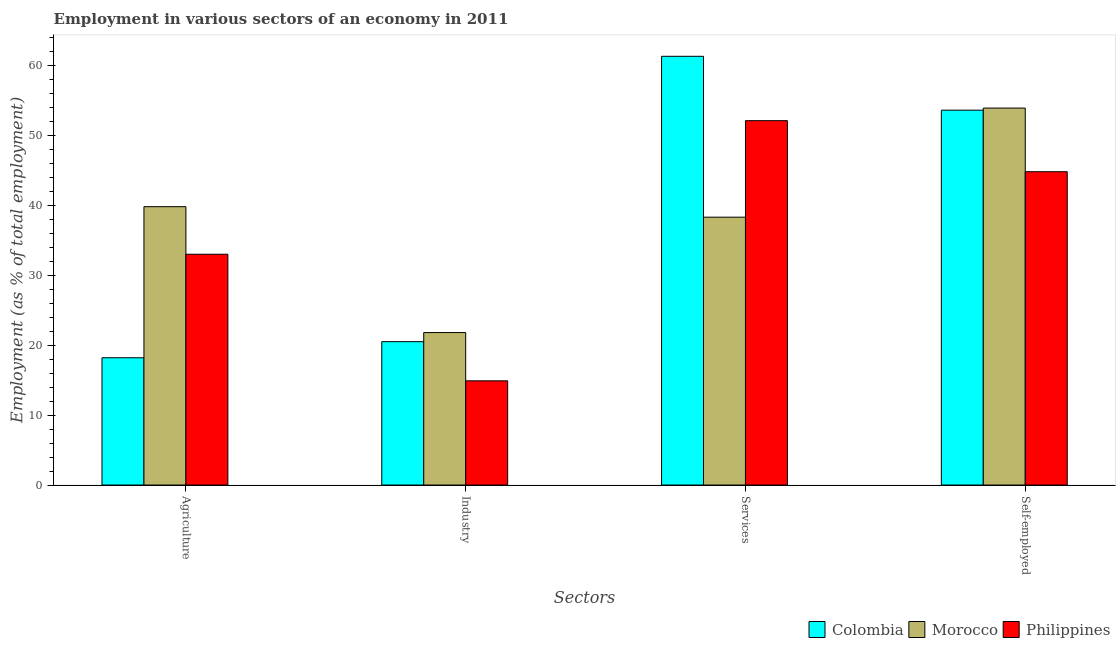How many different coloured bars are there?
Keep it short and to the point. 3. Are the number of bars per tick equal to the number of legend labels?
Ensure brevity in your answer.  Yes. How many bars are there on the 3rd tick from the left?
Make the answer very short. 3. How many bars are there on the 4th tick from the right?
Give a very brief answer. 3. What is the label of the 4th group of bars from the left?
Ensure brevity in your answer.  Self-employed. Across all countries, what is the maximum percentage of workers in services?
Make the answer very short. 61.3. Across all countries, what is the minimum percentage of self employed workers?
Offer a very short reply. 44.8. In which country was the percentage of workers in industry maximum?
Your answer should be very brief. Morocco. In which country was the percentage of self employed workers minimum?
Your answer should be compact. Philippines. What is the total percentage of workers in industry in the graph?
Keep it short and to the point. 57.2. What is the difference between the percentage of self employed workers in Philippines and that in Colombia?
Provide a short and direct response. -8.8. What is the difference between the percentage of workers in industry in Colombia and the percentage of self employed workers in Morocco?
Your answer should be compact. -33.4. What is the average percentage of workers in industry per country?
Make the answer very short. 19.07. What is the difference between the percentage of workers in services and percentage of workers in agriculture in Colombia?
Make the answer very short. 43.1. In how many countries, is the percentage of self employed workers greater than 24 %?
Provide a short and direct response. 3. What is the ratio of the percentage of workers in agriculture in Colombia to that in Philippines?
Keep it short and to the point. 0.55. Is the percentage of self employed workers in Morocco less than that in Philippines?
Provide a succinct answer. No. Is the difference between the percentage of workers in agriculture in Philippines and Morocco greater than the difference between the percentage of self employed workers in Philippines and Morocco?
Keep it short and to the point. Yes. What is the difference between the highest and the second highest percentage of self employed workers?
Offer a terse response. 0.3. What is the difference between the highest and the lowest percentage of workers in industry?
Offer a very short reply. 6.9. Is it the case that in every country, the sum of the percentage of workers in services and percentage of self employed workers is greater than the sum of percentage of workers in agriculture and percentage of workers in industry?
Keep it short and to the point. No. What does the 2nd bar from the left in Agriculture represents?
Make the answer very short. Morocco. What does the 2nd bar from the right in Services represents?
Offer a very short reply. Morocco. Are all the bars in the graph horizontal?
Ensure brevity in your answer.  No. What is the difference between two consecutive major ticks on the Y-axis?
Provide a short and direct response. 10. Are the values on the major ticks of Y-axis written in scientific E-notation?
Offer a very short reply. No. Does the graph contain any zero values?
Offer a very short reply. No. Does the graph contain grids?
Provide a succinct answer. No. Where does the legend appear in the graph?
Your response must be concise. Bottom right. How are the legend labels stacked?
Your response must be concise. Horizontal. What is the title of the graph?
Provide a succinct answer. Employment in various sectors of an economy in 2011. What is the label or title of the X-axis?
Your answer should be very brief. Sectors. What is the label or title of the Y-axis?
Offer a very short reply. Employment (as % of total employment). What is the Employment (as % of total employment) of Colombia in Agriculture?
Make the answer very short. 18.2. What is the Employment (as % of total employment) in Morocco in Agriculture?
Provide a short and direct response. 39.8. What is the Employment (as % of total employment) in Philippines in Agriculture?
Keep it short and to the point. 33. What is the Employment (as % of total employment) of Colombia in Industry?
Give a very brief answer. 20.5. What is the Employment (as % of total employment) in Morocco in Industry?
Keep it short and to the point. 21.8. What is the Employment (as % of total employment) in Philippines in Industry?
Offer a terse response. 14.9. What is the Employment (as % of total employment) of Colombia in Services?
Provide a short and direct response. 61.3. What is the Employment (as % of total employment) of Morocco in Services?
Make the answer very short. 38.3. What is the Employment (as % of total employment) of Philippines in Services?
Provide a short and direct response. 52.1. What is the Employment (as % of total employment) of Colombia in Self-employed?
Offer a terse response. 53.6. What is the Employment (as % of total employment) of Morocco in Self-employed?
Provide a succinct answer. 53.9. What is the Employment (as % of total employment) of Philippines in Self-employed?
Offer a terse response. 44.8. Across all Sectors, what is the maximum Employment (as % of total employment) in Colombia?
Your response must be concise. 61.3. Across all Sectors, what is the maximum Employment (as % of total employment) of Morocco?
Offer a terse response. 53.9. Across all Sectors, what is the maximum Employment (as % of total employment) of Philippines?
Give a very brief answer. 52.1. Across all Sectors, what is the minimum Employment (as % of total employment) of Colombia?
Your answer should be compact. 18.2. Across all Sectors, what is the minimum Employment (as % of total employment) of Morocco?
Your answer should be very brief. 21.8. Across all Sectors, what is the minimum Employment (as % of total employment) in Philippines?
Ensure brevity in your answer.  14.9. What is the total Employment (as % of total employment) in Colombia in the graph?
Make the answer very short. 153.6. What is the total Employment (as % of total employment) in Morocco in the graph?
Provide a succinct answer. 153.8. What is the total Employment (as % of total employment) of Philippines in the graph?
Offer a very short reply. 144.8. What is the difference between the Employment (as % of total employment) of Morocco in Agriculture and that in Industry?
Give a very brief answer. 18. What is the difference between the Employment (as % of total employment) in Colombia in Agriculture and that in Services?
Your response must be concise. -43.1. What is the difference between the Employment (as % of total employment) in Philippines in Agriculture and that in Services?
Provide a succinct answer. -19.1. What is the difference between the Employment (as % of total employment) of Colombia in Agriculture and that in Self-employed?
Make the answer very short. -35.4. What is the difference between the Employment (as % of total employment) in Morocco in Agriculture and that in Self-employed?
Ensure brevity in your answer.  -14.1. What is the difference between the Employment (as % of total employment) in Philippines in Agriculture and that in Self-employed?
Keep it short and to the point. -11.8. What is the difference between the Employment (as % of total employment) in Colombia in Industry and that in Services?
Ensure brevity in your answer.  -40.8. What is the difference between the Employment (as % of total employment) in Morocco in Industry and that in Services?
Provide a succinct answer. -16.5. What is the difference between the Employment (as % of total employment) in Philippines in Industry and that in Services?
Your answer should be very brief. -37.2. What is the difference between the Employment (as % of total employment) of Colombia in Industry and that in Self-employed?
Make the answer very short. -33.1. What is the difference between the Employment (as % of total employment) in Morocco in Industry and that in Self-employed?
Your response must be concise. -32.1. What is the difference between the Employment (as % of total employment) of Philippines in Industry and that in Self-employed?
Your answer should be compact. -29.9. What is the difference between the Employment (as % of total employment) of Morocco in Services and that in Self-employed?
Give a very brief answer. -15.6. What is the difference between the Employment (as % of total employment) of Philippines in Services and that in Self-employed?
Your answer should be compact. 7.3. What is the difference between the Employment (as % of total employment) in Colombia in Agriculture and the Employment (as % of total employment) in Morocco in Industry?
Offer a very short reply. -3.6. What is the difference between the Employment (as % of total employment) in Colombia in Agriculture and the Employment (as % of total employment) in Philippines in Industry?
Give a very brief answer. 3.3. What is the difference between the Employment (as % of total employment) in Morocco in Agriculture and the Employment (as % of total employment) in Philippines in Industry?
Your answer should be compact. 24.9. What is the difference between the Employment (as % of total employment) of Colombia in Agriculture and the Employment (as % of total employment) of Morocco in Services?
Offer a terse response. -20.1. What is the difference between the Employment (as % of total employment) of Colombia in Agriculture and the Employment (as % of total employment) of Philippines in Services?
Your answer should be compact. -33.9. What is the difference between the Employment (as % of total employment) of Morocco in Agriculture and the Employment (as % of total employment) of Philippines in Services?
Offer a very short reply. -12.3. What is the difference between the Employment (as % of total employment) in Colombia in Agriculture and the Employment (as % of total employment) in Morocco in Self-employed?
Keep it short and to the point. -35.7. What is the difference between the Employment (as % of total employment) of Colombia in Agriculture and the Employment (as % of total employment) of Philippines in Self-employed?
Your answer should be compact. -26.6. What is the difference between the Employment (as % of total employment) in Colombia in Industry and the Employment (as % of total employment) in Morocco in Services?
Your answer should be compact. -17.8. What is the difference between the Employment (as % of total employment) of Colombia in Industry and the Employment (as % of total employment) of Philippines in Services?
Your answer should be compact. -31.6. What is the difference between the Employment (as % of total employment) in Morocco in Industry and the Employment (as % of total employment) in Philippines in Services?
Ensure brevity in your answer.  -30.3. What is the difference between the Employment (as % of total employment) of Colombia in Industry and the Employment (as % of total employment) of Morocco in Self-employed?
Give a very brief answer. -33.4. What is the difference between the Employment (as % of total employment) in Colombia in Industry and the Employment (as % of total employment) in Philippines in Self-employed?
Your answer should be compact. -24.3. What is the difference between the Employment (as % of total employment) of Morocco in Industry and the Employment (as % of total employment) of Philippines in Self-employed?
Keep it short and to the point. -23. What is the difference between the Employment (as % of total employment) in Colombia in Services and the Employment (as % of total employment) in Morocco in Self-employed?
Offer a terse response. 7.4. What is the difference between the Employment (as % of total employment) of Colombia in Services and the Employment (as % of total employment) of Philippines in Self-employed?
Provide a succinct answer. 16.5. What is the average Employment (as % of total employment) of Colombia per Sectors?
Make the answer very short. 38.4. What is the average Employment (as % of total employment) of Morocco per Sectors?
Keep it short and to the point. 38.45. What is the average Employment (as % of total employment) in Philippines per Sectors?
Your answer should be compact. 36.2. What is the difference between the Employment (as % of total employment) of Colombia and Employment (as % of total employment) of Morocco in Agriculture?
Offer a terse response. -21.6. What is the difference between the Employment (as % of total employment) in Colombia and Employment (as % of total employment) in Philippines in Agriculture?
Offer a terse response. -14.8. What is the difference between the Employment (as % of total employment) of Morocco and Employment (as % of total employment) of Philippines in Agriculture?
Your answer should be very brief. 6.8. What is the difference between the Employment (as % of total employment) of Colombia and Employment (as % of total employment) of Philippines in Industry?
Your answer should be very brief. 5.6. What is the difference between the Employment (as % of total employment) of Colombia and Employment (as % of total employment) of Philippines in Services?
Provide a short and direct response. 9.2. What is the difference between the Employment (as % of total employment) in Morocco and Employment (as % of total employment) in Philippines in Services?
Your answer should be very brief. -13.8. What is the difference between the Employment (as % of total employment) of Colombia and Employment (as % of total employment) of Philippines in Self-employed?
Ensure brevity in your answer.  8.8. What is the ratio of the Employment (as % of total employment) of Colombia in Agriculture to that in Industry?
Your response must be concise. 0.89. What is the ratio of the Employment (as % of total employment) in Morocco in Agriculture to that in Industry?
Ensure brevity in your answer.  1.83. What is the ratio of the Employment (as % of total employment) in Philippines in Agriculture to that in Industry?
Your answer should be compact. 2.21. What is the ratio of the Employment (as % of total employment) of Colombia in Agriculture to that in Services?
Your answer should be compact. 0.3. What is the ratio of the Employment (as % of total employment) of Morocco in Agriculture to that in Services?
Keep it short and to the point. 1.04. What is the ratio of the Employment (as % of total employment) of Philippines in Agriculture to that in Services?
Ensure brevity in your answer.  0.63. What is the ratio of the Employment (as % of total employment) in Colombia in Agriculture to that in Self-employed?
Provide a short and direct response. 0.34. What is the ratio of the Employment (as % of total employment) in Morocco in Agriculture to that in Self-employed?
Give a very brief answer. 0.74. What is the ratio of the Employment (as % of total employment) of Philippines in Agriculture to that in Self-employed?
Provide a short and direct response. 0.74. What is the ratio of the Employment (as % of total employment) of Colombia in Industry to that in Services?
Give a very brief answer. 0.33. What is the ratio of the Employment (as % of total employment) in Morocco in Industry to that in Services?
Provide a succinct answer. 0.57. What is the ratio of the Employment (as % of total employment) of Philippines in Industry to that in Services?
Provide a short and direct response. 0.29. What is the ratio of the Employment (as % of total employment) of Colombia in Industry to that in Self-employed?
Your response must be concise. 0.38. What is the ratio of the Employment (as % of total employment) in Morocco in Industry to that in Self-employed?
Give a very brief answer. 0.4. What is the ratio of the Employment (as % of total employment) in Philippines in Industry to that in Self-employed?
Provide a succinct answer. 0.33. What is the ratio of the Employment (as % of total employment) in Colombia in Services to that in Self-employed?
Give a very brief answer. 1.14. What is the ratio of the Employment (as % of total employment) in Morocco in Services to that in Self-employed?
Your response must be concise. 0.71. What is the ratio of the Employment (as % of total employment) in Philippines in Services to that in Self-employed?
Ensure brevity in your answer.  1.16. What is the difference between the highest and the second highest Employment (as % of total employment) of Colombia?
Offer a very short reply. 7.7. What is the difference between the highest and the second highest Employment (as % of total employment) in Morocco?
Make the answer very short. 14.1. What is the difference between the highest and the lowest Employment (as % of total employment) of Colombia?
Make the answer very short. 43.1. What is the difference between the highest and the lowest Employment (as % of total employment) in Morocco?
Give a very brief answer. 32.1. What is the difference between the highest and the lowest Employment (as % of total employment) of Philippines?
Provide a short and direct response. 37.2. 